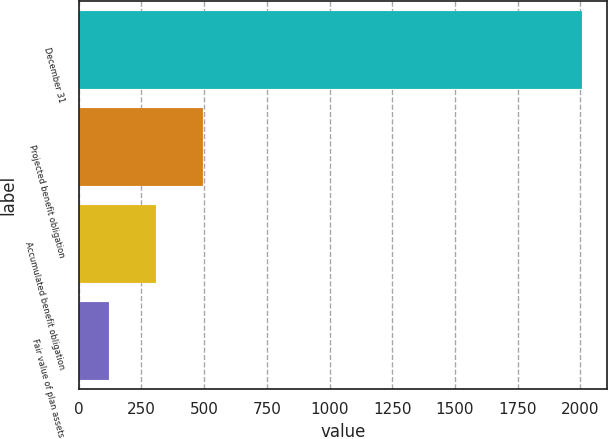Convert chart to OTSL. <chart><loc_0><loc_0><loc_500><loc_500><bar_chart><fcel>December 31<fcel>Projected benefit obligation<fcel>Accumulated benefit obligation<fcel>Fair value of plan assets<nl><fcel>2006<fcel>497.2<fcel>308.6<fcel>120<nl></chart> 